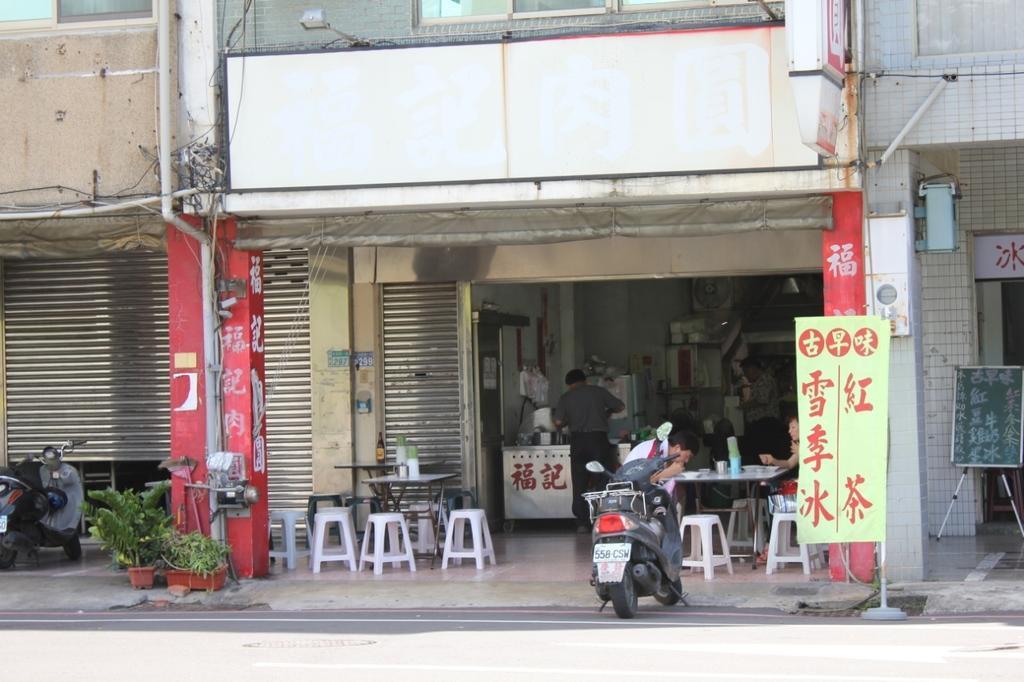Can you describe this image briefly? In this picture we can see building, in which we can see a shop, few people are sitting on the chairs and we can see few vehicles, potted plants. 